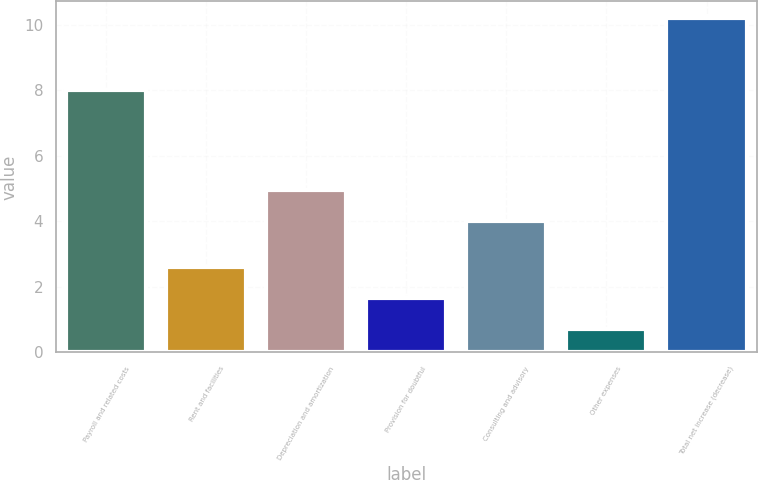<chart> <loc_0><loc_0><loc_500><loc_500><bar_chart><fcel>Payroll and related costs<fcel>Rent and facilities<fcel>Depreciation and amortization<fcel>Provision for doubtful<fcel>Consulting and advisory<fcel>Other expenses<fcel>Total net increase (decrease)<nl><fcel>8<fcel>2.6<fcel>4.95<fcel>1.65<fcel>4<fcel>0.7<fcel>10.2<nl></chart> 